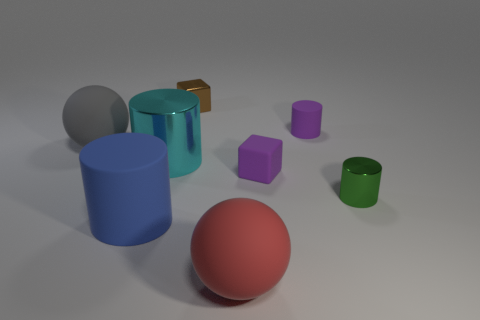What is the color of the large object that is both in front of the large gray ball and behind the purple cube?
Offer a terse response. Cyan. There is a cylinder in front of the green metal thing; is it the same size as the cube on the left side of the red thing?
Offer a very short reply. No. What number of balls are the same color as the tiny matte cube?
Ensure brevity in your answer.  0. What number of small objects are cyan matte blocks or purple matte cylinders?
Your answer should be compact. 1. Do the small cube behind the large cyan object and the big blue object have the same material?
Keep it short and to the point. No. There is a large ball that is behind the small green cylinder; what is its color?
Keep it short and to the point. Gray. Are there any cyan rubber objects that have the same size as the brown thing?
Offer a very short reply. No. There is another purple block that is the same size as the metal cube; what is it made of?
Offer a very short reply. Rubber. Do the purple matte cylinder and the metal thing that is to the right of the metal block have the same size?
Give a very brief answer. Yes. There is a big thing on the right side of the large cyan shiny cylinder; what is its material?
Ensure brevity in your answer.  Rubber. 